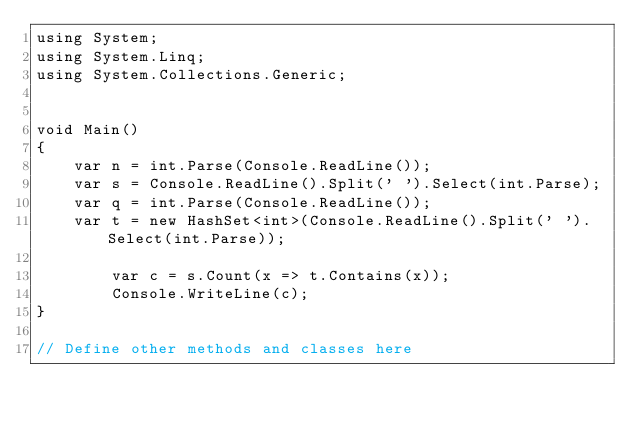Convert code to text. <code><loc_0><loc_0><loc_500><loc_500><_C#_>using System;
using System.Linq;
using System.Collections.Generic;


void Main()
{
    var n = int.Parse(Console.ReadLine());
    var s = Console.ReadLine().Split(' ').Select(int.Parse);
    var q = int.Parse(Console.ReadLine());
    var t = new HashSet<int>(Console.ReadLine().Split(' ').Select(int.Parse));

        var c = s.Count(x => t.Contains(x));
        Console.WriteLine(c);
}

// Define other methods and classes here</code> 